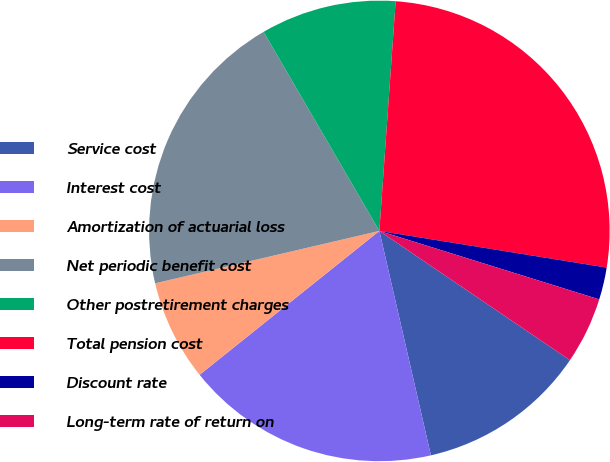Convert chart. <chart><loc_0><loc_0><loc_500><loc_500><pie_chart><fcel>Service cost<fcel>Interest cost<fcel>Amortization of actuarial loss<fcel>Net periodic benefit cost<fcel>Other postretirement charges<fcel>Total pension cost<fcel>Discount rate<fcel>Long-term rate of return on<nl><fcel>11.92%<fcel>17.85%<fcel>7.09%<fcel>20.27%<fcel>9.51%<fcel>26.42%<fcel>2.26%<fcel>4.68%<nl></chart> 